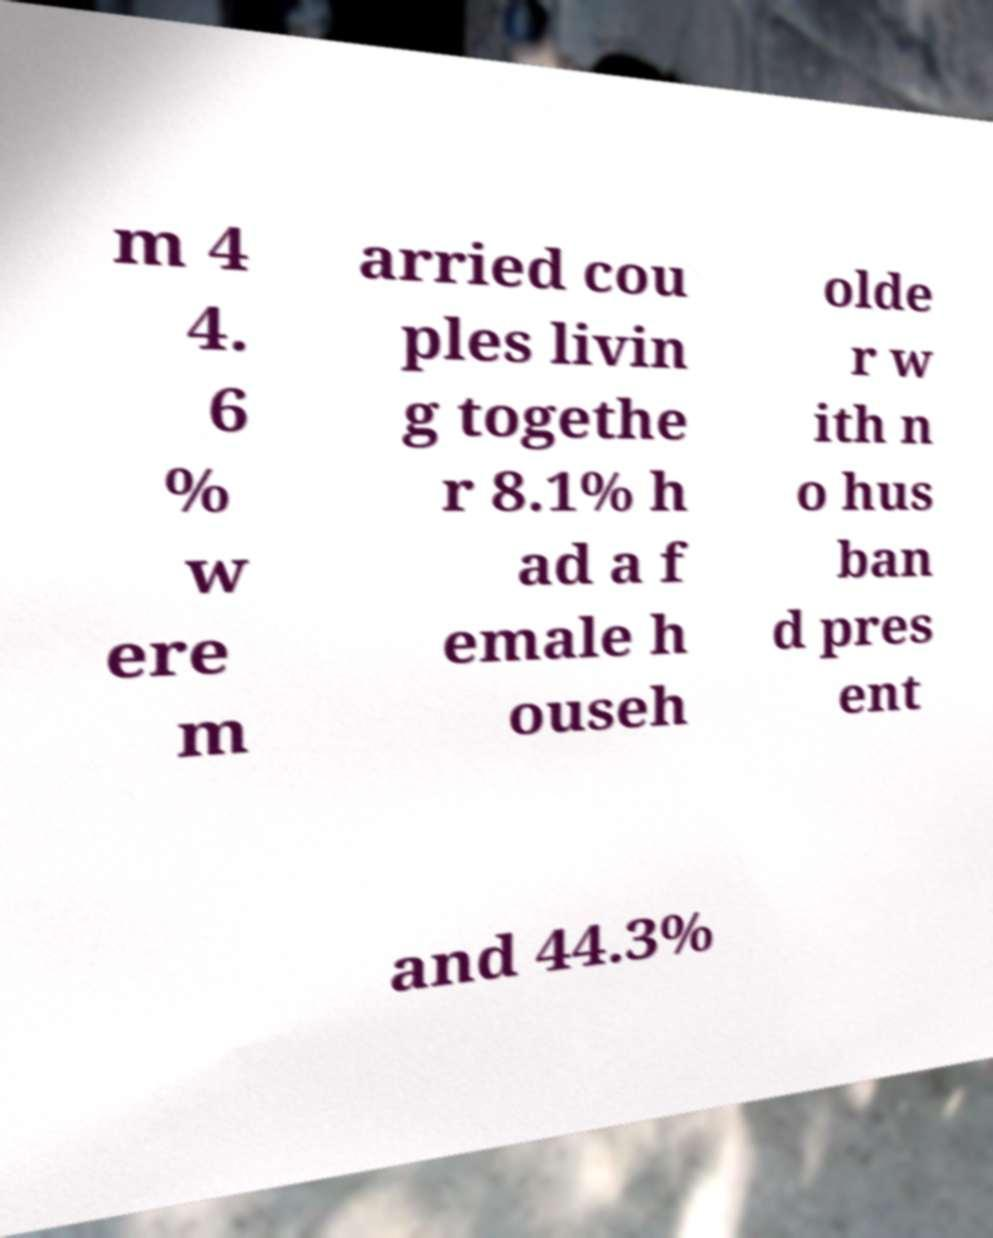Could you assist in decoding the text presented in this image and type it out clearly? m 4 4. 6 % w ere m arried cou ples livin g togethe r 8.1% h ad a f emale h ouseh olde r w ith n o hus ban d pres ent and 44.3% 